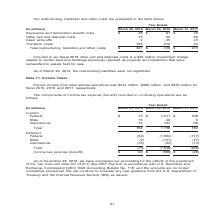According to Nortonlifelock's financial document, What does the table show? components of income tax expense (benefit) recorded in continuing operations. The document states: "The components of income tax expense (benefit) recorded in continuing operations are as follows:..." Also, What is the Pre-tax income from international operations for fiscal 2019? According to the financial document, $214 million. The relevant text states: "Pre-tax income from international operations was $214 million, $890 million, and $353 million for fiscal 2019, 2018, and 2017, respectively...." Also, What is the Pre-tax income from international operations for fiscal 2018? According to the financial document, $890 million. The relevant text states: "me from international operations was $214 million, $890 million, and $353 million for fiscal 2019, 2018, and 2017, respectively...." Also, can you calculate: What is the income tax expense for Federal for year ended March 29, 2019 expressed as a percentage of total income tax expenses? Based on the calculation: 73/162, the result is 45.06 (percentage). This is based on the information: "Total 162 1,158 182 turing, transition and other costs $ 241 $ 410 $ 273..." The key data points involved are: 162, 73. Also, can you calculate: What is the summed Total current income tax expense for the fiscal years 2017, 2018 and 2019? Based on the calculation: 162+1,158+182, the result is 1502 (in millions). This is based on the information: "Total 162 1,158 182 Total 162 1,158 182 Total 162 1,158 182..." The key data points involved are: 1,158, 162, 182. Also, can you calculate: What is the average Total current income tax expense for the fiscal years 2017, 2018 and 2019? To answer this question, I need to perform calculations using the financial data. The calculation is: (162+1,158+182)/3, which equals 500.67 (in millions). This is based on the information: "Total 162 1,158 182 Total 162 1,158 182 Total 162 1,158 182..." The key data points involved are: 1,158, 162, 182. 